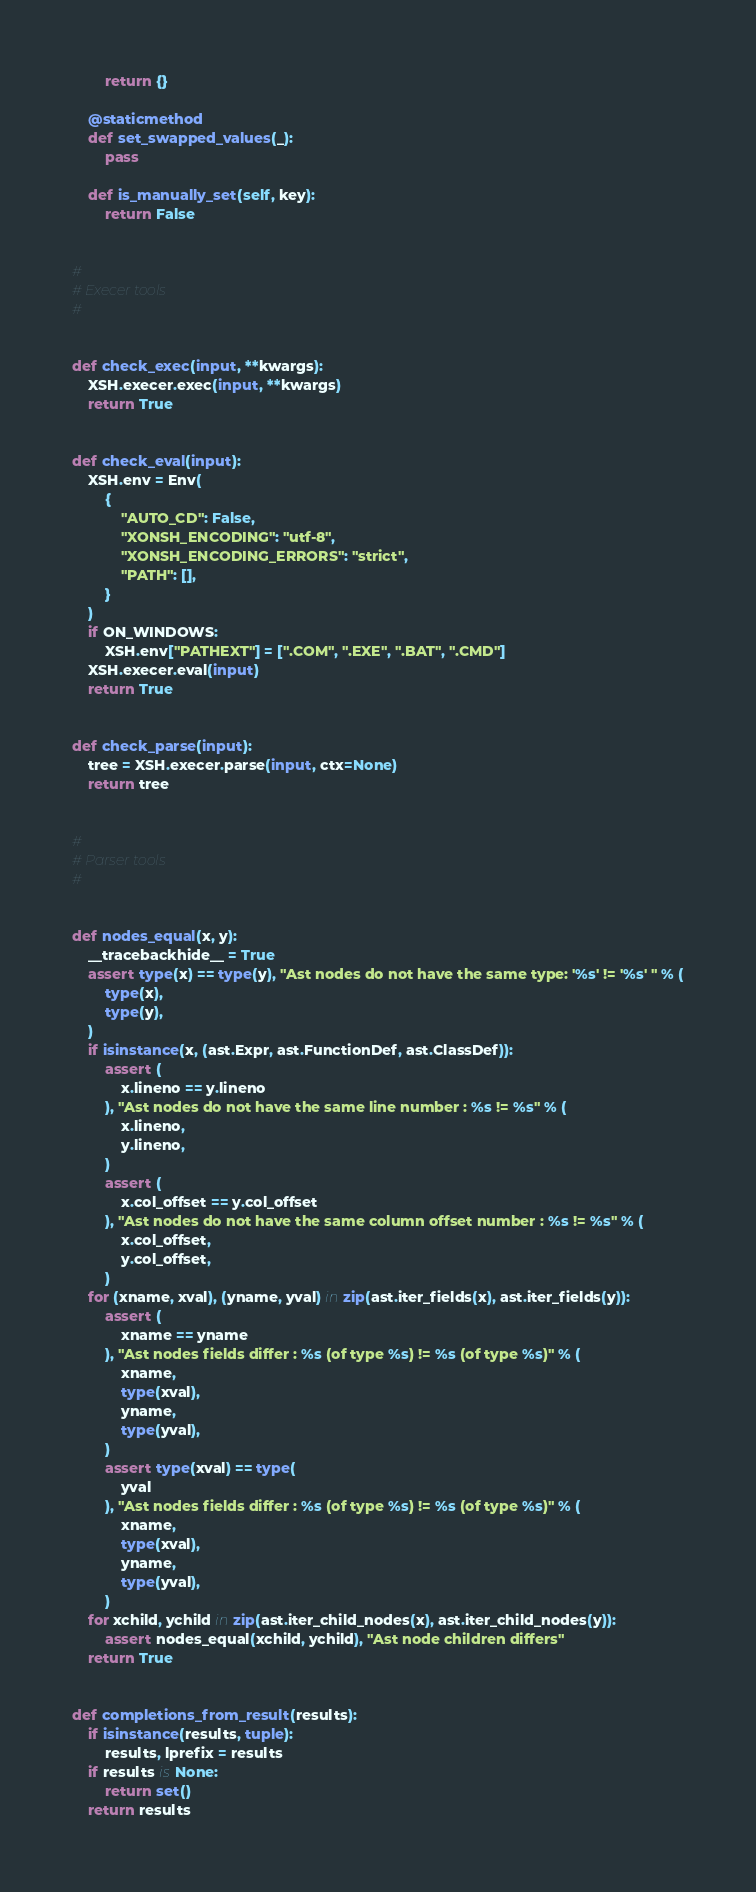Convert code to text. <code><loc_0><loc_0><loc_500><loc_500><_Python_>        return {}

    @staticmethod
    def set_swapped_values(_):
        pass

    def is_manually_set(self, key):
        return False


#
# Execer tools
#


def check_exec(input, **kwargs):
    XSH.execer.exec(input, **kwargs)
    return True


def check_eval(input):
    XSH.env = Env(
        {
            "AUTO_CD": False,
            "XONSH_ENCODING": "utf-8",
            "XONSH_ENCODING_ERRORS": "strict",
            "PATH": [],
        }
    )
    if ON_WINDOWS:
        XSH.env["PATHEXT"] = [".COM", ".EXE", ".BAT", ".CMD"]
    XSH.execer.eval(input)
    return True


def check_parse(input):
    tree = XSH.execer.parse(input, ctx=None)
    return tree


#
# Parser tools
#


def nodes_equal(x, y):
    __tracebackhide__ = True
    assert type(x) == type(y), "Ast nodes do not have the same type: '%s' != '%s' " % (
        type(x),
        type(y),
    )
    if isinstance(x, (ast.Expr, ast.FunctionDef, ast.ClassDef)):
        assert (
            x.lineno == y.lineno
        ), "Ast nodes do not have the same line number : %s != %s" % (
            x.lineno,
            y.lineno,
        )
        assert (
            x.col_offset == y.col_offset
        ), "Ast nodes do not have the same column offset number : %s != %s" % (
            x.col_offset,
            y.col_offset,
        )
    for (xname, xval), (yname, yval) in zip(ast.iter_fields(x), ast.iter_fields(y)):
        assert (
            xname == yname
        ), "Ast nodes fields differ : %s (of type %s) != %s (of type %s)" % (
            xname,
            type(xval),
            yname,
            type(yval),
        )
        assert type(xval) == type(
            yval
        ), "Ast nodes fields differ : %s (of type %s) != %s (of type %s)" % (
            xname,
            type(xval),
            yname,
            type(yval),
        )
    for xchild, ychild in zip(ast.iter_child_nodes(x), ast.iter_child_nodes(y)):
        assert nodes_equal(xchild, ychild), "Ast node children differs"
    return True


def completions_from_result(results):
    if isinstance(results, tuple):
        results, lprefix = results
    if results is None:
        return set()
    return results
</code> 